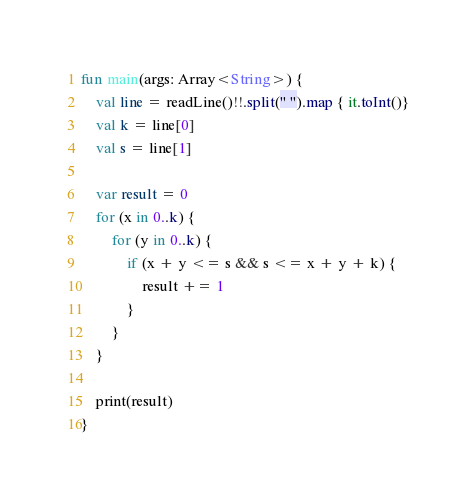Convert code to text. <code><loc_0><loc_0><loc_500><loc_500><_Kotlin_>fun main(args: Array<String>) {
    val line = readLine()!!.split(" ").map { it.toInt()}
    val k = line[0]
    val s = line[1]

    var result = 0
    for (x in 0..k) {
        for (y in 0..k) {
            if (x + y <= s && s <= x + y + k) {
                result += 1
            }
        }
    }

    print(result)
}</code> 